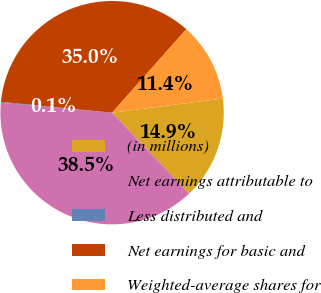Convert chart to OTSL. <chart><loc_0><loc_0><loc_500><loc_500><pie_chart><fcel>(in millions)<fcel>Net earnings attributable to<fcel>Less distributed and<fcel>Net earnings for basic and<fcel>Weighted-average shares for<nl><fcel>14.92%<fcel>38.52%<fcel>0.12%<fcel>35.02%<fcel>11.42%<nl></chart> 